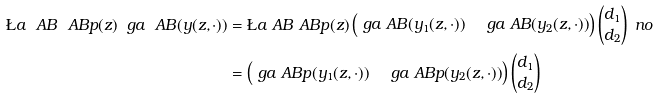Convert formula to latex. <formula><loc_0><loc_0><loc_500><loc_500>\L a _ { \ } A B ^ { \ } A B p ( z ) \ g a _ { \ } A B ( y ( z , \cdot ) ) & = \L a _ { \ } A B ^ { \ } A B p ( z ) \begin{pmatrix} \ g a _ { \ } A B ( y _ { 1 } ( z , \cdot ) ) & \ g a _ { \ } A B ( y _ { 2 } ( z , \cdot ) ) \end{pmatrix} \begin{pmatrix} d _ { 1 } \\ d _ { 2 } \end{pmatrix} \ n o \\ & = \begin{pmatrix} \ g a _ { \ } A B p ( y _ { 1 } ( z , \cdot ) ) & \ g a _ { \ } A B p ( y _ { 2 } ( z , \cdot ) ) \end{pmatrix} \begin{pmatrix} d _ { 1 } \\ d _ { 2 } \end{pmatrix}</formula> 